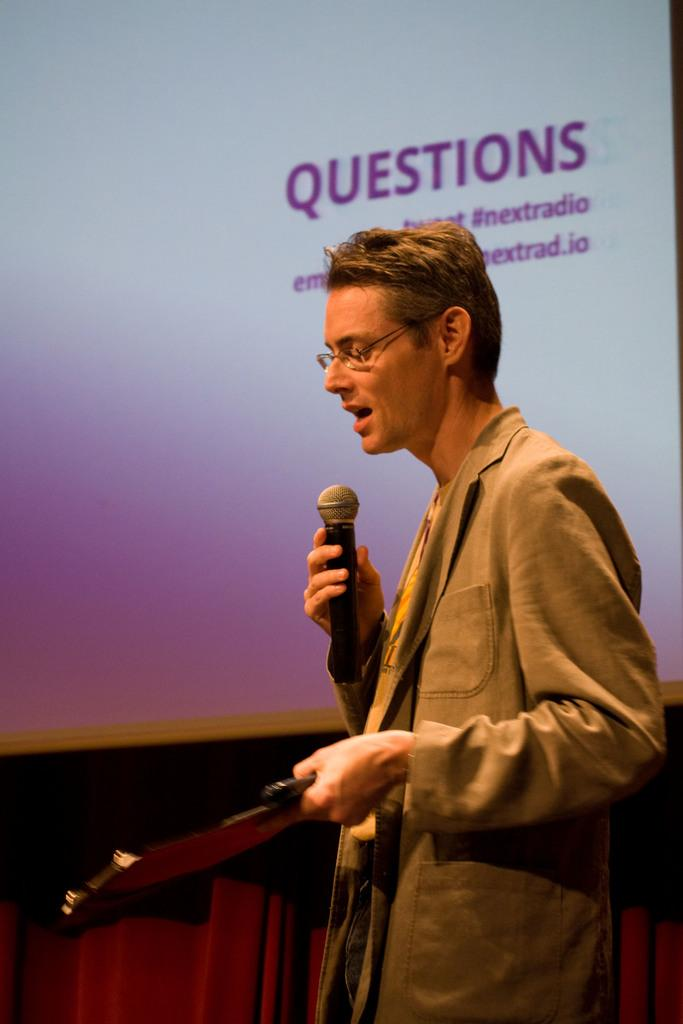Who is present in the image? There is a man in the image. What is the man holding in his hand? The man is holding a mic in his hand. What type of floor can be seen in the image? There is no information about the floor in the image, as the facts provided only mention the man and the mic he is holding. 